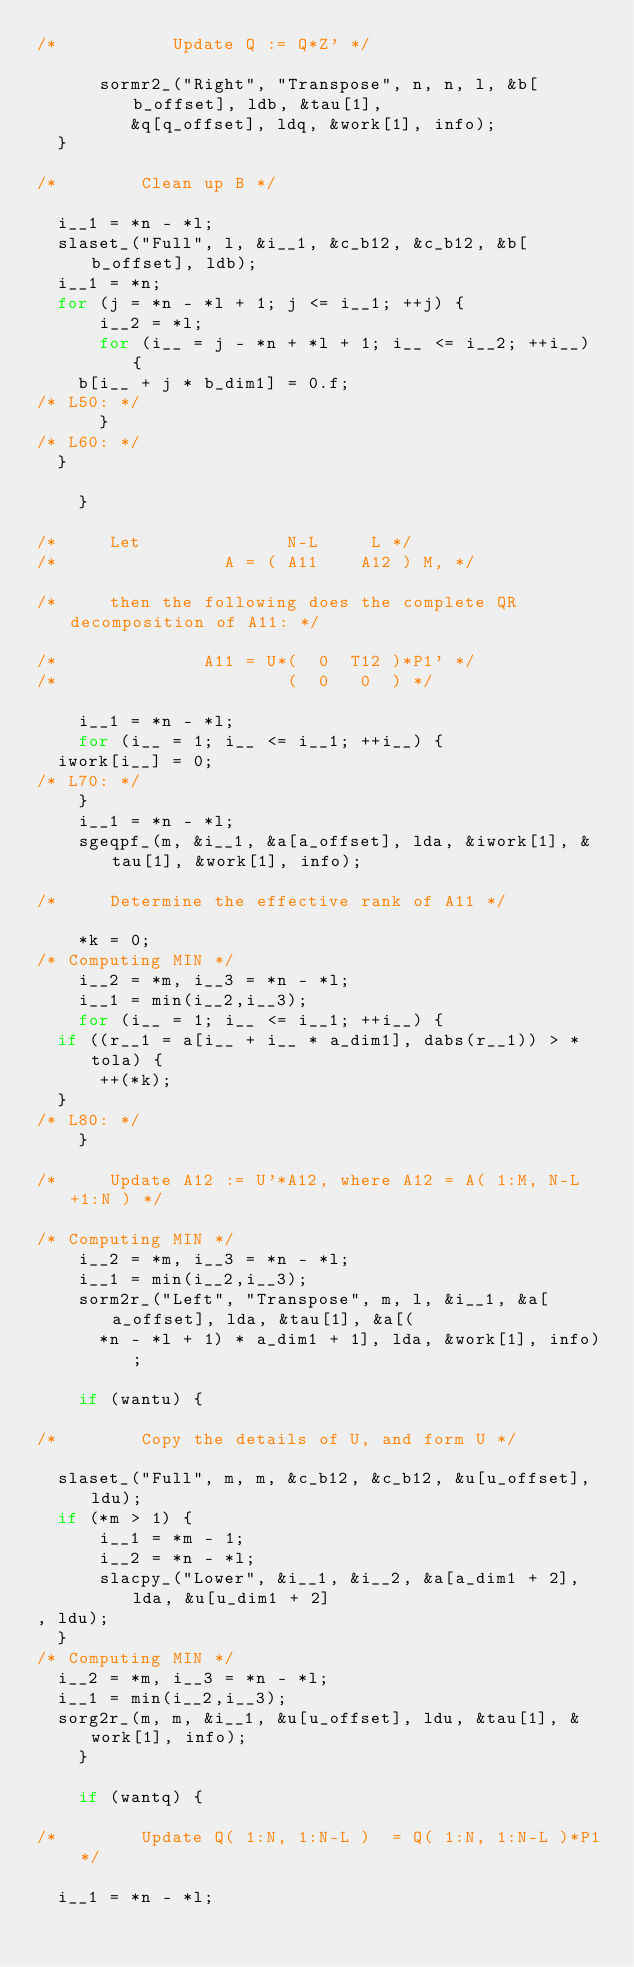Convert code to text. <code><loc_0><loc_0><loc_500><loc_500><_C_>/*           Update Q := Q*Z' */

	    sormr2_("Right", "Transpose", n, n, l, &b[b_offset], ldb, &tau[1], 
		     &q[q_offset], ldq, &work[1], info);
	}

/*        Clean up B */

	i__1 = *n - *l;
	slaset_("Full", l, &i__1, &c_b12, &c_b12, &b[b_offset], ldb);
	i__1 = *n;
	for (j = *n - *l + 1; j <= i__1; ++j) {
	    i__2 = *l;
	    for (i__ = j - *n + *l + 1; i__ <= i__2; ++i__) {
		b[i__ + j * b_dim1] = 0.f;
/* L50: */
	    }
/* L60: */
	}

    }

/*     Let              N-L     L */
/*                A = ( A11    A12 ) M, */

/*     then the following does the complete QR decomposition of A11: */

/*              A11 = U*(  0  T12 )*P1' */
/*                      (  0   0  ) */

    i__1 = *n - *l;
    for (i__ = 1; i__ <= i__1; ++i__) {
	iwork[i__] = 0;
/* L70: */
    }
    i__1 = *n - *l;
    sgeqpf_(m, &i__1, &a[a_offset], lda, &iwork[1], &tau[1], &work[1], info);

/*     Determine the effective rank of A11 */

    *k = 0;
/* Computing MIN */
    i__2 = *m, i__3 = *n - *l;
    i__1 = min(i__2,i__3);
    for (i__ = 1; i__ <= i__1; ++i__) {
	if ((r__1 = a[i__ + i__ * a_dim1], dabs(r__1)) > *tola) {
	    ++(*k);
	}
/* L80: */
    }

/*     Update A12 := U'*A12, where A12 = A( 1:M, N-L+1:N ) */

/* Computing MIN */
    i__2 = *m, i__3 = *n - *l;
    i__1 = min(i__2,i__3);
    sorm2r_("Left", "Transpose", m, l, &i__1, &a[a_offset], lda, &tau[1], &a[(
	    *n - *l + 1) * a_dim1 + 1], lda, &work[1], info);

    if (wantu) {

/*        Copy the details of U, and form U */

	slaset_("Full", m, m, &c_b12, &c_b12, &u[u_offset], ldu);
	if (*m > 1) {
	    i__1 = *m - 1;
	    i__2 = *n - *l;
	    slacpy_("Lower", &i__1, &i__2, &a[a_dim1 + 2], lda, &u[u_dim1 + 2]
, ldu);
	}
/* Computing MIN */
	i__2 = *m, i__3 = *n - *l;
	i__1 = min(i__2,i__3);
	sorg2r_(m, m, &i__1, &u[u_offset], ldu, &tau[1], &work[1], info);
    }

    if (wantq) {

/*        Update Q( 1:N, 1:N-L )  = Q( 1:N, 1:N-L )*P1 */

	i__1 = *n - *l;</code> 